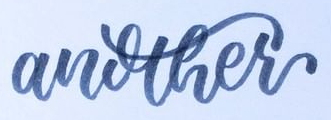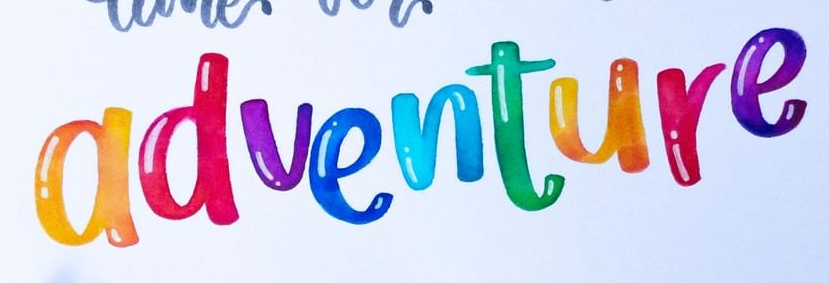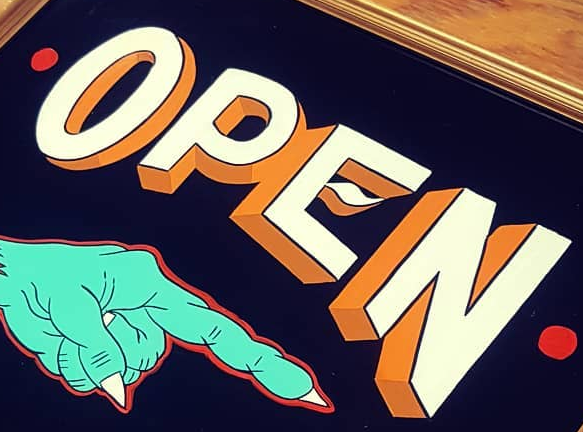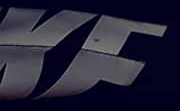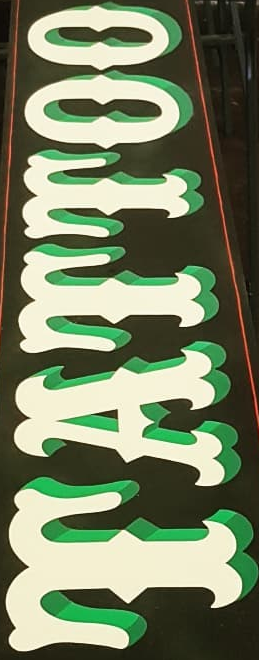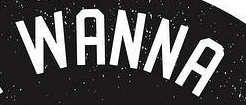Identify the words shown in these images in order, separated by a semicolon. another; adventure; OPEN; KF; TATTOO; WANNA 